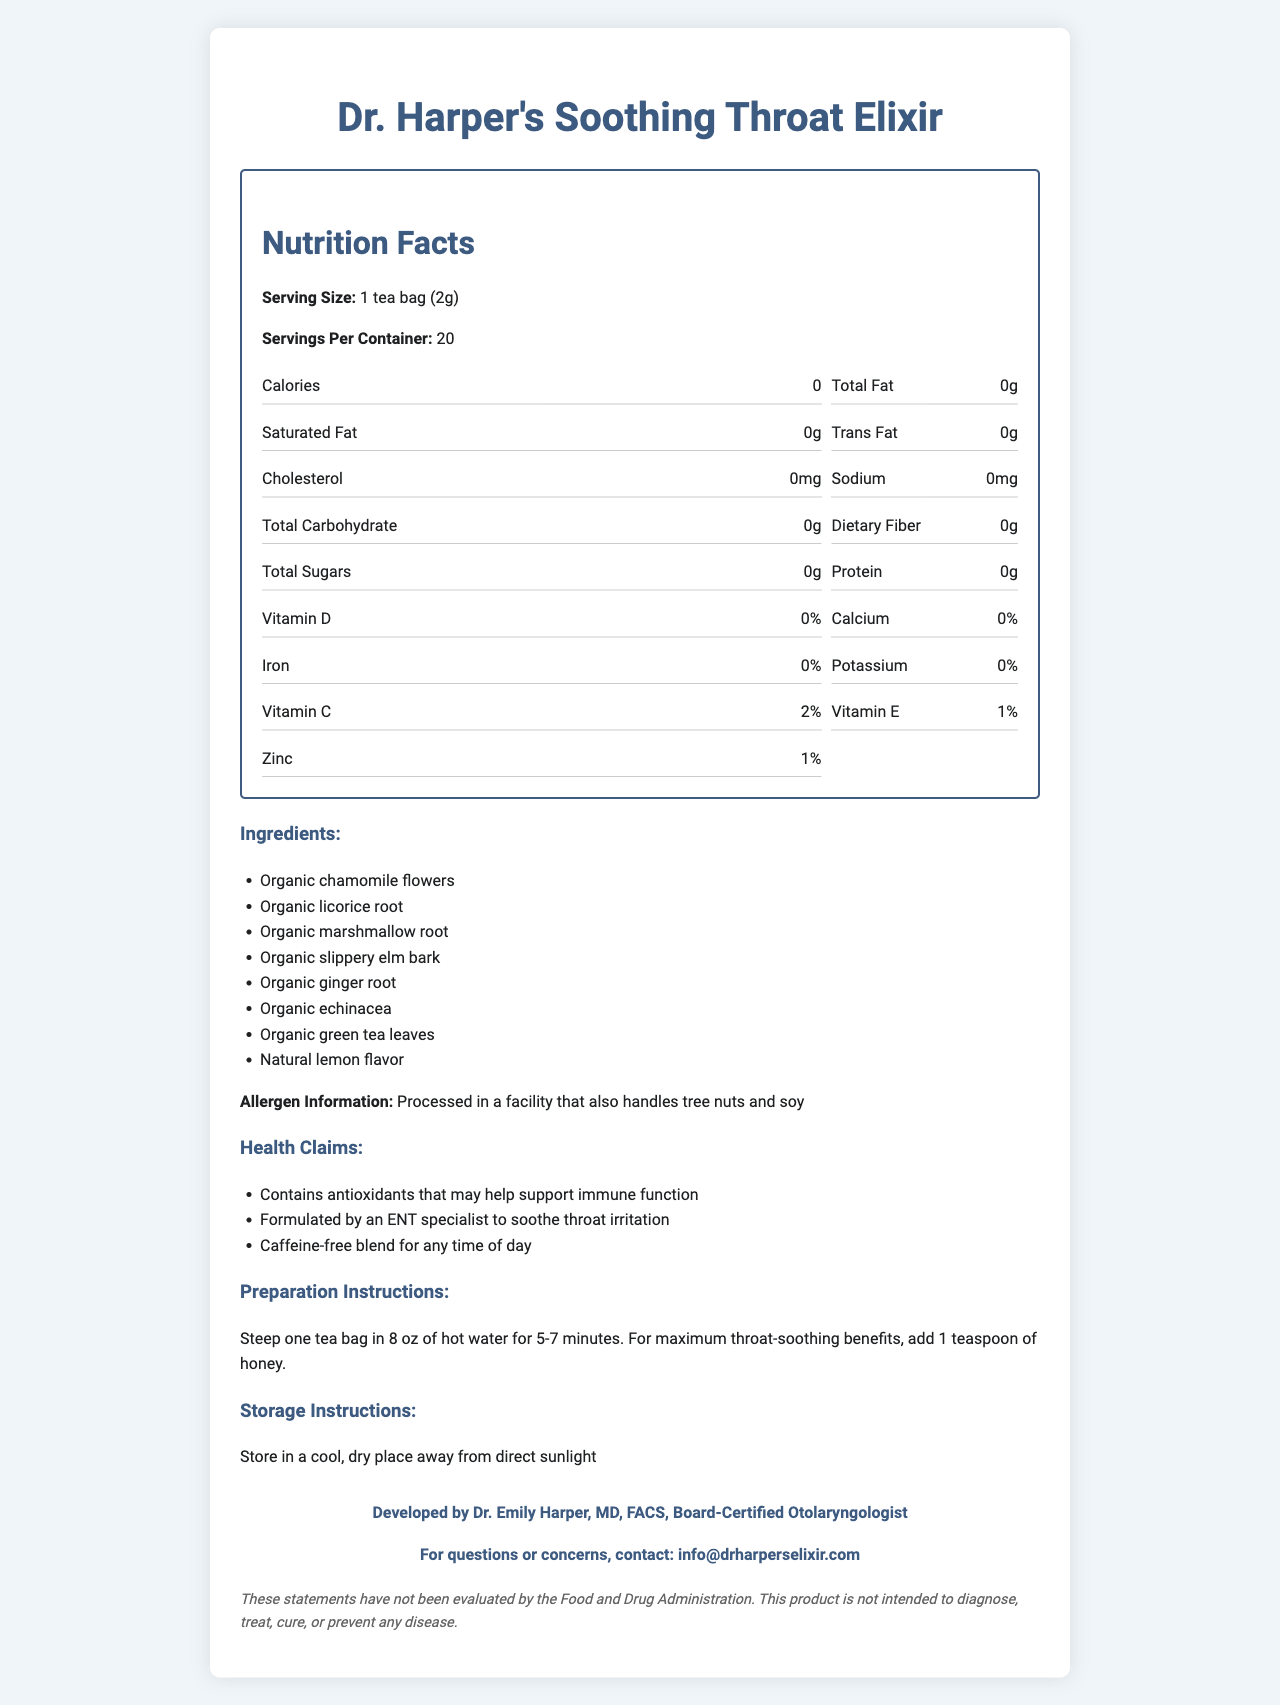what is the serving size for Dr. Harper's Soothing Throat Elixir? The serving size is stated directly under the "Nutrition Facts" section.
Answer: 1 tea bag (2g) how many servings are contained in one container of the tea? This information is found under the "Servings Per Container" in the "Nutrition Facts" section.
Answer: 20 servings how much vitamin C does each serving provide? The "Nutrition Facts" section lists the vitamin C content as 2%.
Answer: 2% list three ingredients in Dr. Harper's Soothing Throat Elixir. The ingredients are listed in a bullet-point list under the "Ingredients" section.
Answer: Organic chamomile flowers, Organic licorice root, Organic marshmallow root how much protein is in each serving of the tea? The protein content is listed as 0g in the "Nutrition Facts" section.
Answer: 0g which of the following vitamins are present in the tea? A. Vitamin A B. Vitamin C C. Vitamin D D. Vitamin B12 The "Nutrition Facts" section lists vitamins present in the tea, and vitamin C is one of them.
Answer: B. Vitamin C what is the allergen information for the tea? A. Contains tree nuts B. Contains soy C. Processed in a facility that handles nuts and soy D. Contains dairy The allergen information specifically mentions that the product is processed in a facility that also handles tree nuts and soy.
Answer: C. Processed in a facility that handles nuts and soy is the tea caffeinated? The health claims section notes that the blend is "Caffeine-free".
Answer: No what are the preparation instructions? The preparation instructions are detailed in a specific section for ease of use.
Answer: Steep one tea bag in 8 oz of hot water for 5-7 minutes. For maximum throat-soothing benefits, add 1 teaspoon of honey. does the tea provide any fat content? The "Nutrition Facts" section lists Total Fat, Saturated Fat, and Trans Fat all as 0g.
Answer: No who developed Dr. Harper's Soothing Throat Elixir? This information is listed under the "Manufacturer Info" section.
Answer: Dr. Emily Harper, MD, FACS, Board-Certified Otolaryngologist what is the main health benefit claimed for this tea? Among the health claims, the primary benefit noted is the antioxidant content that may support immune function.
Answer: Contains antioxidants that may help support immune function summarize the main details provided in the document. This summary captures the product's purpose, main benefits, nutritional content, preparation, and additional relevant details.
Answer: Dr. Harper's Soothing Throat Elixir is a caffeine-free herbal tea blend developed by Dr. Emily Harper, intended to soothe throat irritation and support immune function due to its antioxidant content. It contains 0 calories, fat, carbs, sugars, and protein per serving and is free of allergens but processed in a facility that handles tree nuts and soy. Preparation involves steeping a tea bag in hot water, with an optional addition of honey. The document also includes storage instructions and contact information. are there any artificial colors or flavors in the tea? The ingredients list does not specifically mention artificial colors or flavors, so there's insufficient information to answer this.
Answer: Cannot be determined what percentage of daily iron is provided by each serving? The iron content is listed as 0% in the "Nutrition Facts" section.
Answer: 0% is the tea suitable for someone who is allergic to soy? The allergen information specifies that the tea is processed in a facility that also handles soy.
Answer: No what storage conditions are recommended for the tea? This information is listed under the "Storage Instructions" section.
Answer: Store in a cool, dry place away from direct sunlight 